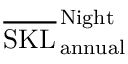<formula> <loc_0><loc_0><loc_500><loc_500>\overline { S K L } _ { \, a n n u a l } ^ { \, N i g h t }</formula> 